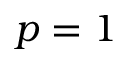Convert formula to latex. <formula><loc_0><loc_0><loc_500><loc_500>p = 1</formula> 